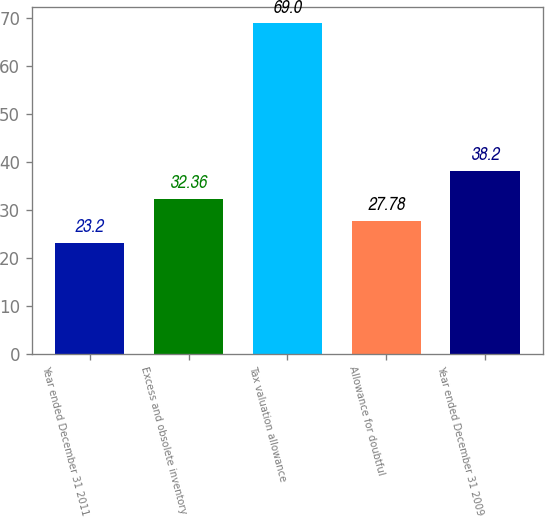Convert chart to OTSL. <chart><loc_0><loc_0><loc_500><loc_500><bar_chart><fcel>Year ended December 31 2011<fcel>Excess and obsolete inventory<fcel>Tax valuation allowance<fcel>Allowance for doubtful<fcel>Year ended December 31 2009<nl><fcel>23.2<fcel>32.36<fcel>69<fcel>27.78<fcel>38.2<nl></chart> 